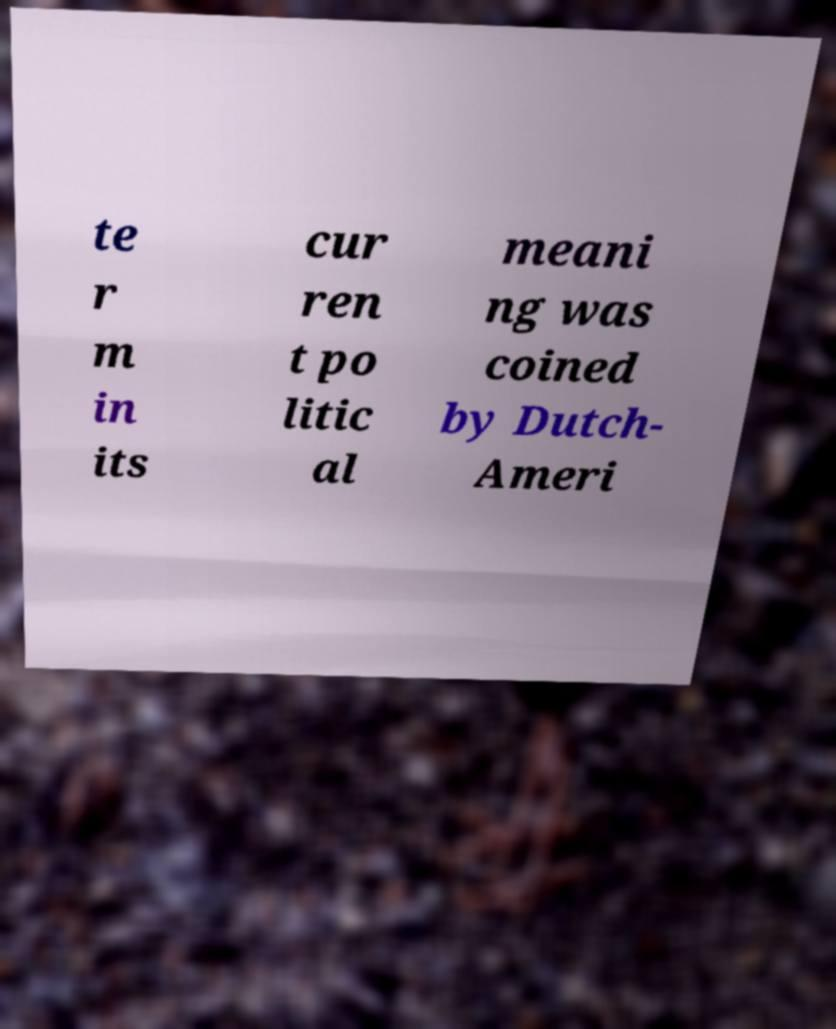There's text embedded in this image that I need extracted. Can you transcribe it verbatim? te r m in its cur ren t po litic al meani ng was coined by Dutch- Ameri 